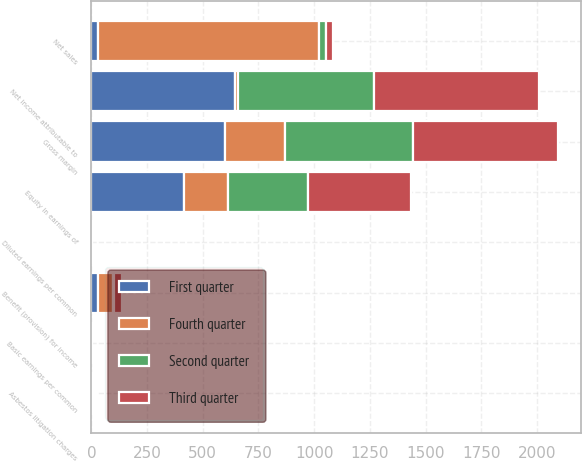<chart> <loc_0><loc_0><loc_500><loc_500><stacked_bar_chart><ecel><fcel>Net sales<fcel>Gross margin<fcel>Asbestos litigation charges<fcel>Equity in earnings of<fcel>Benefit (provision) for income<fcel>Net income attributable to<fcel>Basic earnings per common<fcel>Diluted earnings per common<nl><fcel>Fourth quarter<fcel>989<fcel>270<fcel>4<fcel>195<fcel>66<fcel>14<fcel>0.01<fcel>0.01<nl><fcel>Second quarter<fcel>32<fcel>575<fcel>5<fcel>361<fcel>4<fcel>611<fcel>0.39<fcel>0.39<nl><fcel>First quarter<fcel>32<fcel>599<fcel>6<fcel>418<fcel>32<fcel>643<fcel>0.41<fcel>0.41<nl><fcel>Third quarter<fcel>32<fcel>649<fcel>5<fcel>461<fcel>36<fcel>740<fcel>0.48<fcel>0.47<nl></chart> 